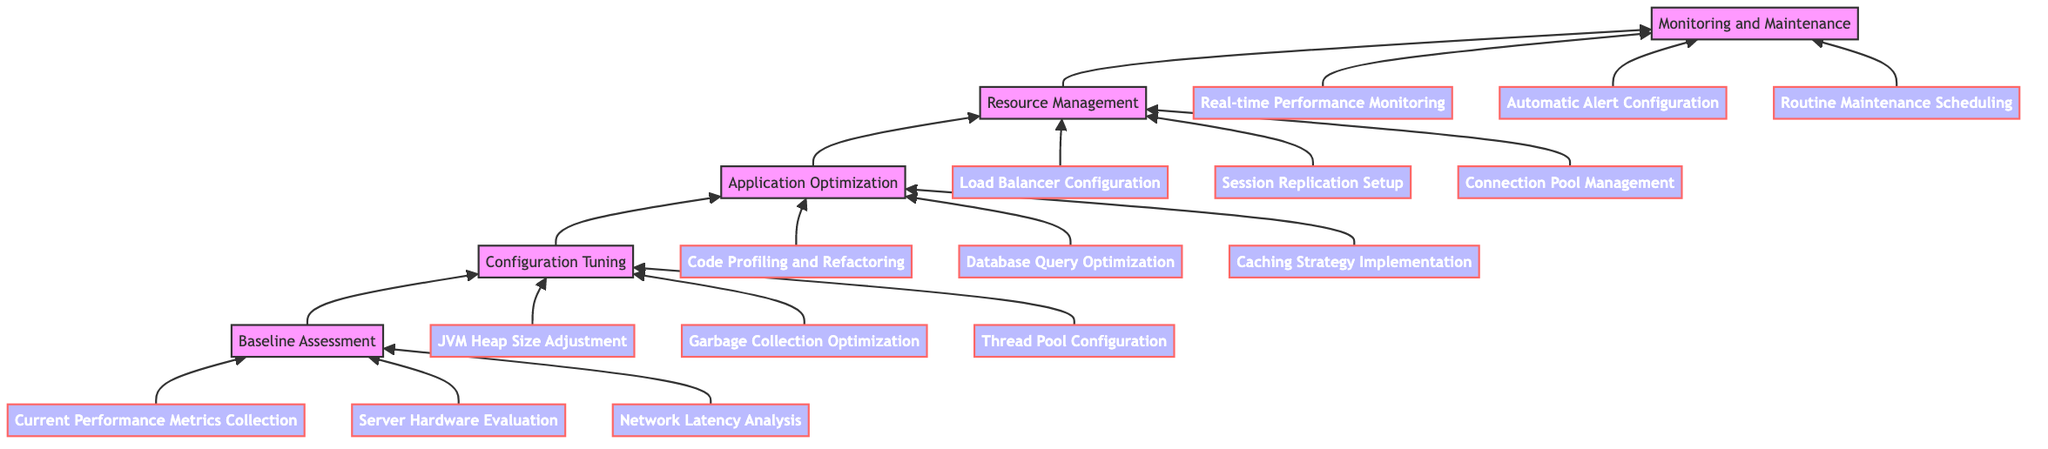What are the three elements in the Baseline Assessment? The Baseline Assessment level contains three elements: Current Performance Metrics Collection, Server Hardware Evaluation, and Network Latency Analysis.
Answer: Current Performance Metrics Collection, Server Hardware Evaluation, Network Latency Analysis How many levels are present in the flow chart? The flow chart contains five distinct levels: Baseline Assessment, Configuration Tuning, Application Optimization, Resource Management, and Monitoring and Maintenance.
Answer: Five Which node follows the Configuration Tuning node? The Configuration Tuning node directly leads to the Application Optimization node in the upward flow of the chart.
Answer: Application Optimization What is the last node in the flow chart? The flow chart ends at the Monitoring and Maintenance node, which is the topmost element in the structure.
Answer: Monitoring and Maintenance What elements are part of Resource Management? Resource Management has three elements: Load Balancer Configuration, Session Replication Setup, and Connection Pool Management.
Answer: Load Balancer Configuration, Session Replication Setup, Connection Pool Management Which node is below Application Optimization? The node beneath the Application Optimization in the upward flow is the Configuration Tuning node.
Answer: Configuration Tuning What type of optimization is associated with the last level in the chart? The final level, Monitoring and Maintenance, is associated with real-time performance and routine maintenance strategies to ensure optimal operation.
Answer: Monitoring and Maintenance How many elements are present under the Monitoring and Maintenance level? There are three elements under Monitoring and Maintenance: Real-time Performance Monitoring, Automatic Alert Configuration, and Routine Maintenance Scheduling.
Answer: Three Which level comes after Application Optimization? Following the Application Optimization level in the upward flow is the Resource Management level, which focuses on managing system resources effectively.
Answer: Resource Management 